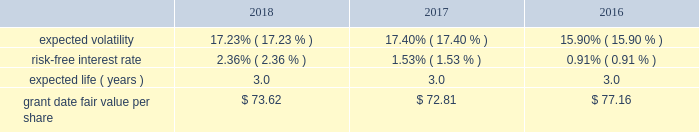Condition are valued using a monte carlo model .
Expected volatility is based on historical volatilities of traded common stock of the company and comparative companies using daily stock prices over the past three years .
The expected term is three years and the risk-free interest rate is based on the three-year u.s .
Treasury rate in effect as of the measurement date .
The table provides the weighted average assumptions used in the monte carlo simulation and the weighted average grant date fair values of psus granted for the years ended december 31: .
The grant date fair value of psus that vest ratably and have market and/or performance conditions are amortized through expense over the requisite service period using the graded-vesting method .
If dividends are paid with respect to shares of the company 2019s common stock before the rsus and psus are distributed , the company credits a liability for the value of the dividends that would have been paid if the rsus and psus were shares of company common stock .
When the rsus and psus are distributed , the company pays the participant a lump sum cash payment equal to the value of the dividend equivalents accrued .
The company accrued dividend equivalents totaling $ 1 million , less than $ 1 million and $ 1 million to accumulated deficit in the accompanying consolidated statements of changes in shareholders 2019 equity for the years ended december 31 , 2018 , 2017 and 2016 , respectively .
Employee stock purchase plan the company maintains a nonqualified employee stock purchase plan ( the 201cespp 201d ) through which employee participants may use payroll deductions to acquire company common stock at a discount .
Prior to february 5 , 2019 , the purchase price of common stock acquired under the espp was the lesser of 90% ( 90 % ) of the fair market value of the common stock at either the beginning or the end of a three -month purchase period .
On july 27 , 2018 , the espp was amended , effective february 5 , 2019 , to permit employee participants to acquire company common stock at 85% ( 85 % ) of the fair market value of the common stock at the end of the purchase period .
As of december 31 , 2018 , there were 1.9 million shares of common stock reserved for issuance under the espp .
The espp is considered compensatory .
During the years ended december 31 , 2018 , 2017 and 2016 , the company issued 95 thousand , 93 thousand and 93 thousand shares , respectively , under the espp. .
What was the minimum grant date fair value per share in the table? 
Computations: table_min(grant date fair value per share, none)
Answer: 72.81. 